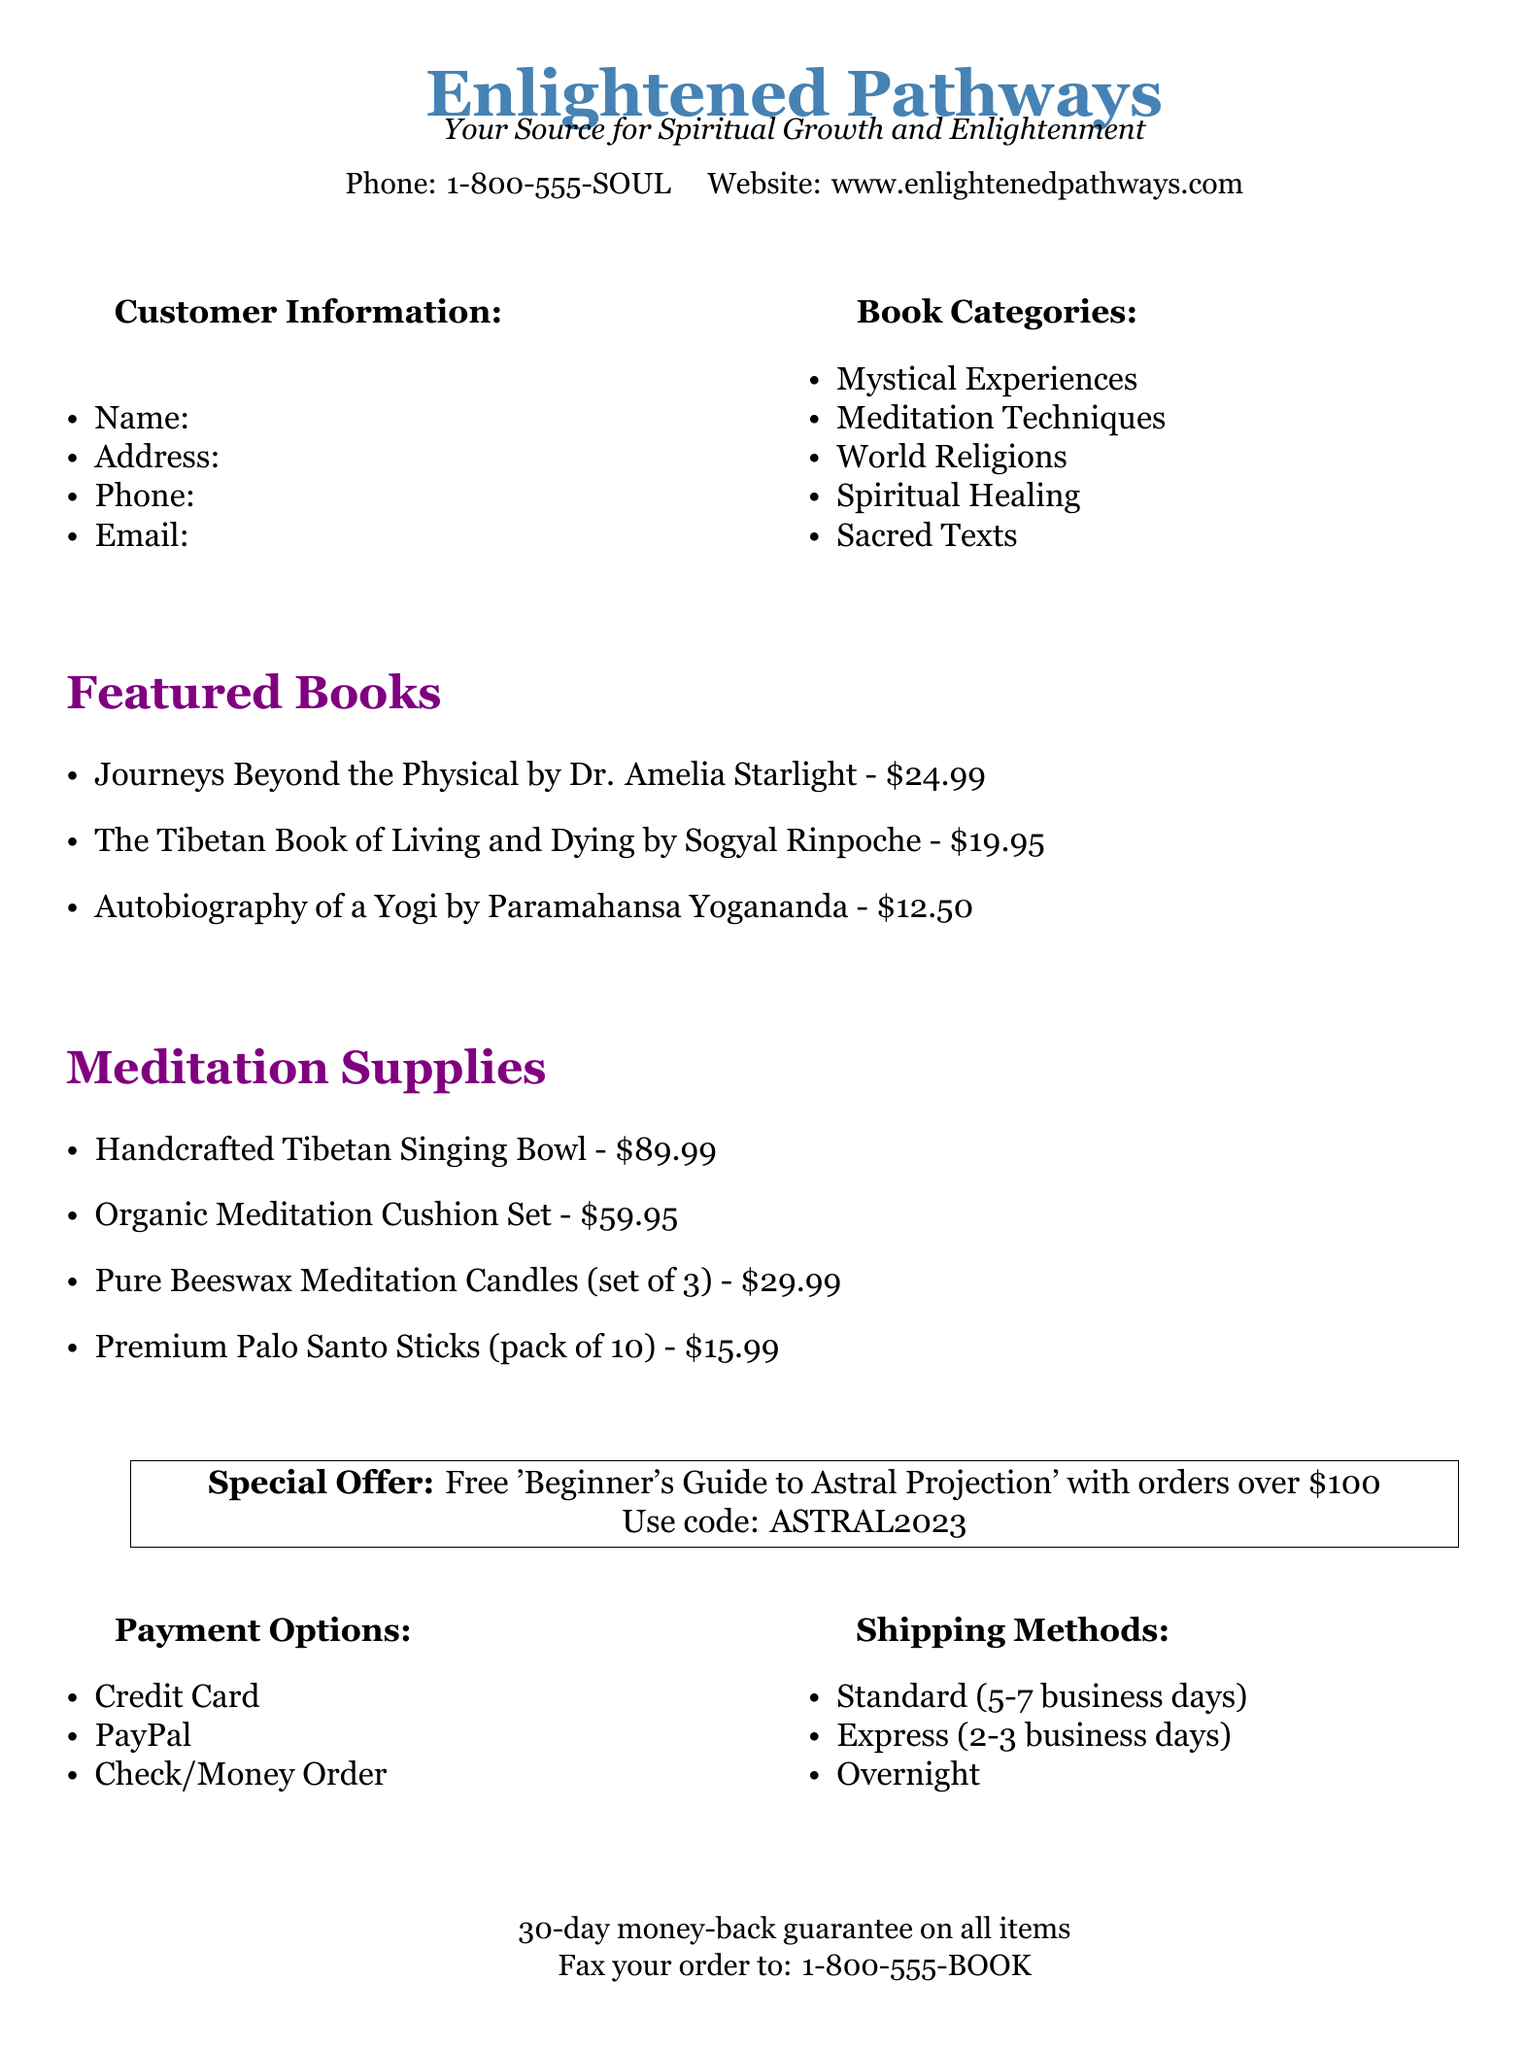What is the name of the featured book by Dr. Amelia Starlight? The document lists "Journeys Beyond the Physical" as a featured book by Dr. Amelia Starlight.
Answer: Journeys Beyond the Physical What is the price of the Tibetan Book of Living and Dying? The document specifies that "The Tibetan Book of Living and Dying" costs $19.95.
Answer: $19.95 What is the discount offer with orders over $100? The document mentions that a free 'Beginner's Guide to Astral Projection' is offered with qualifying orders.
Answer: Free 'Beginner's Guide to Astral Projection' What payment options are available? The document lists credit card, PayPal, and check/money order as payment options.
Answer: Credit Card, PayPal, Check/Money Order How many meditation candles are in a set? The document states that the Pure Beeswax Meditation Candles come in a set of 3.
Answer: Set of 3 What is the contact phone number for Enlightened Pathways? The document provides the contact phone number as 1-800-555-SOUL.
Answer: 1-800-555-SOUL What is the shipping method with the fastest delivery? The document specifies "Overnight" as the fastest shipping method available.
Answer: Overnight What is the 30-day policy mentioned in the document? The document states there is a money-back guarantee on all items for 30 days.
Answer: Money-back guarantee What is the default font used in the document? The document indicates that Georgia is the main font used throughout.
Answer: Georgia 